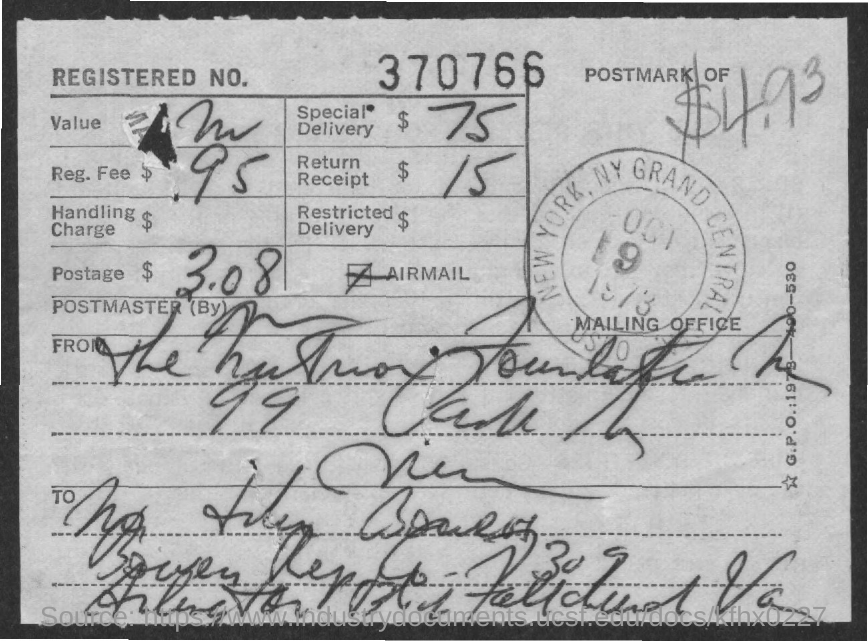What is the Registered No.?
Offer a very short reply. 370766. What is the Reg. Fee?
Provide a short and direct response. $ .95. What is the fee for Special Delivery?
Your answer should be compact. $ 75. What is the fee for Return Receipt?
Keep it short and to the point. $ 15. 